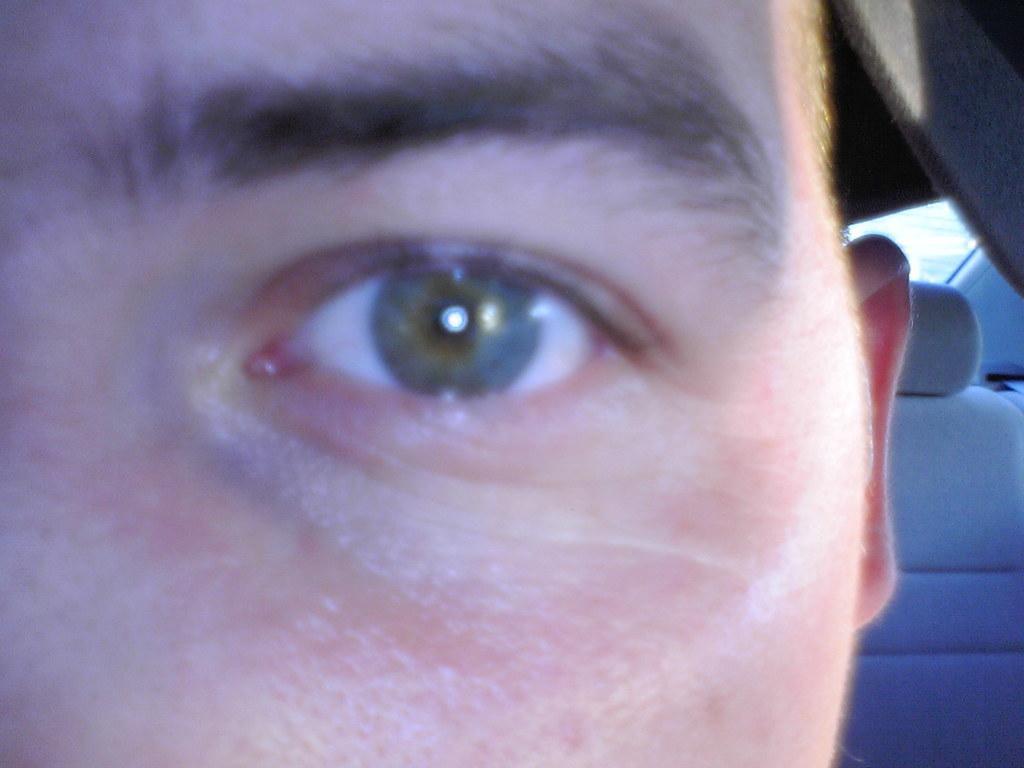In one or two sentences, can you explain what this image depicts? In this picture I can see a human and looks like a seat in the vehicle. 